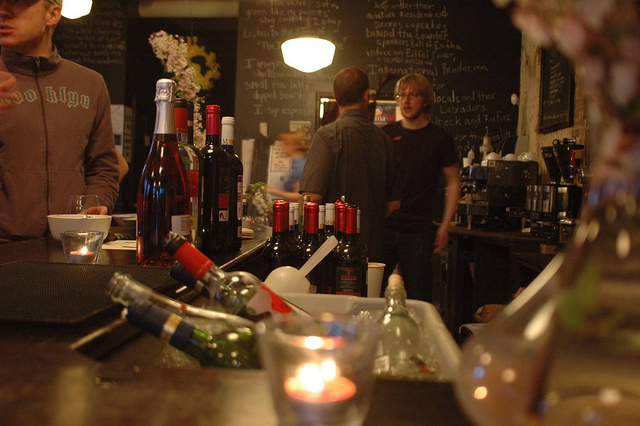<image>What does the person on the lefts hoodie read? I am not sure what the hoodie reads. It could say 'Brooklyn', 'Zoophilia', 'Oaklyn', or 'Olga'. What does the person on the lefts hoodie read? I don't know what the person on the left's hoodie reads. It can be seen as 'brooklyn', 'zoophilia' or 'oaklyn'. 